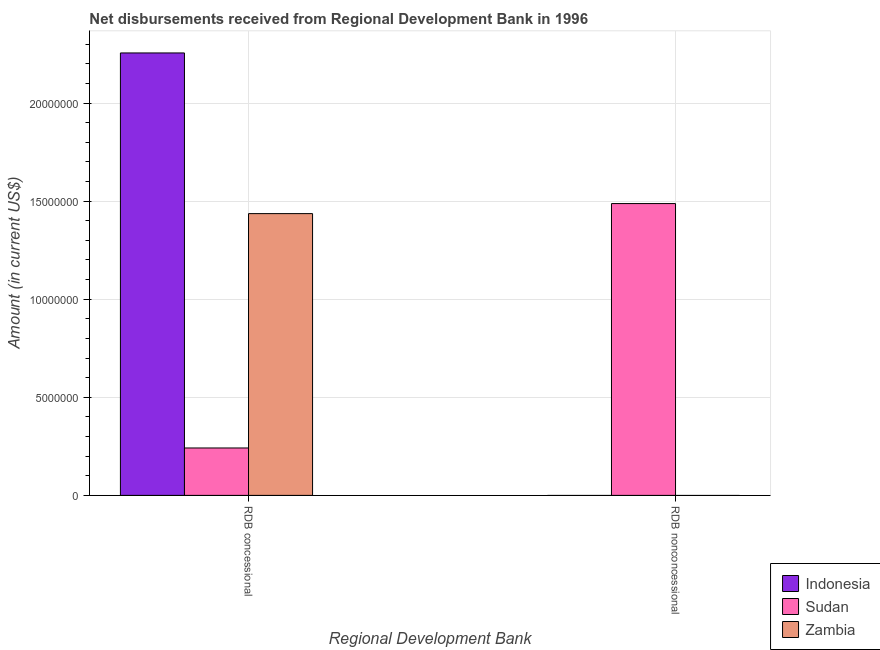How many different coloured bars are there?
Make the answer very short. 3. Are the number of bars per tick equal to the number of legend labels?
Give a very brief answer. No. Are the number of bars on each tick of the X-axis equal?
Offer a very short reply. No. How many bars are there on the 2nd tick from the left?
Provide a succinct answer. 1. What is the label of the 2nd group of bars from the left?
Make the answer very short. RDB nonconcessional. What is the net concessional disbursements from rdb in Indonesia?
Your response must be concise. 2.26e+07. Across all countries, what is the maximum net concessional disbursements from rdb?
Provide a short and direct response. 2.26e+07. Across all countries, what is the minimum net non concessional disbursements from rdb?
Keep it short and to the point. 0. In which country was the net concessional disbursements from rdb maximum?
Give a very brief answer. Indonesia. What is the total net non concessional disbursements from rdb in the graph?
Ensure brevity in your answer.  1.49e+07. What is the difference between the net concessional disbursements from rdb in Zambia and that in Indonesia?
Ensure brevity in your answer.  -8.19e+06. What is the difference between the net non concessional disbursements from rdb in Zambia and the net concessional disbursements from rdb in Sudan?
Offer a terse response. -2.42e+06. What is the average net concessional disbursements from rdb per country?
Offer a very short reply. 1.31e+07. What is the difference between the net non concessional disbursements from rdb and net concessional disbursements from rdb in Sudan?
Make the answer very short. 1.25e+07. What is the ratio of the net concessional disbursements from rdb in Sudan to that in Indonesia?
Provide a short and direct response. 0.11. How many bars are there?
Provide a succinct answer. 4. How many countries are there in the graph?
Provide a succinct answer. 3. Are the values on the major ticks of Y-axis written in scientific E-notation?
Ensure brevity in your answer.  No. Does the graph contain grids?
Provide a succinct answer. Yes. Where does the legend appear in the graph?
Ensure brevity in your answer.  Bottom right. How many legend labels are there?
Offer a very short reply. 3. How are the legend labels stacked?
Provide a succinct answer. Vertical. What is the title of the graph?
Provide a short and direct response. Net disbursements received from Regional Development Bank in 1996. Does "Guinea-Bissau" appear as one of the legend labels in the graph?
Provide a succinct answer. No. What is the label or title of the X-axis?
Provide a short and direct response. Regional Development Bank. What is the Amount (in current US$) in Indonesia in RDB concessional?
Offer a terse response. 2.26e+07. What is the Amount (in current US$) in Sudan in RDB concessional?
Make the answer very short. 2.42e+06. What is the Amount (in current US$) of Zambia in RDB concessional?
Offer a terse response. 1.44e+07. What is the Amount (in current US$) in Indonesia in RDB nonconcessional?
Your answer should be very brief. 0. What is the Amount (in current US$) of Sudan in RDB nonconcessional?
Offer a terse response. 1.49e+07. What is the Amount (in current US$) in Zambia in RDB nonconcessional?
Give a very brief answer. 0. Across all Regional Development Bank, what is the maximum Amount (in current US$) in Indonesia?
Give a very brief answer. 2.26e+07. Across all Regional Development Bank, what is the maximum Amount (in current US$) in Sudan?
Give a very brief answer. 1.49e+07. Across all Regional Development Bank, what is the maximum Amount (in current US$) in Zambia?
Your response must be concise. 1.44e+07. Across all Regional Development Bank, what is the minimum Amount (in current US$) of Indonesia?
Your response must be concise. 0. Across all Regional Development Bank, what is the minimum Amount (in current US$) of Sudan?
Ensure brevity in your answer.  2.42e+06. What is the total Amount (in current US$) of Indonesia in the graph?
Your answer should be very brief. 2.26e+07. What is the total Amount (in current US$) of Sudan in the graph?
Keep it short and to the point. 1.73e+07. What is the total Amount (in current US$) in Zambia in the graph?
Provide a succinct answer. 1.44e+07. What is the difference between the Amount (in current US$) in Sudan in RDB concessional and that in RDB nonconcessional?
Provide a short and direct response. -1.25e+07. What is the difference between the Amount (in current US$) in Indonesia in RDB concessional and the Amount (in current US$) in Sudan in RDB nonconcessional?
Your answer should be compact. 7.68e+06. What is the average Amount (in current US$) in Indonesia per Regional Development Bank?
Offer a terse response. 1.13e+07. What is the average Amount (in current US$) in Sudan per Regional Development Bank?
Offer a terse response. 8.65e+06. What is the average Amount (in current US$) in Zambia per Regional Development Bank?
Offer a very short reply. 7.18e+06. What is the difference between the Amount (in current US$) in Indonesia and Amount (in current US$) in Sudan in RDB concessional?
Provide a succinct answer. 2.01e+07. What is the difference between the Amount (in current US$) of Indonesia and Amount (in current US$) of Zambia in RDB concessional?
Offer a very short reply. 8.19e+06. What is the difference between the Amount (in current US$) of Sudan and Amount (in current US$) of Zambia in RDB concessional?
Your answer should be compact. -1.19e+07. What is the ratio of the Amount (in current US$) in Sudan in RDB concessional to that in RDB nonconcessional?
Offer a terse response. 0.16. What is the difference between the highest and the second highest Amount (in current US$) in Sudan?
Offer a very short reply. 1.25e+07. What is the difference between the highest and the lowest Amount (in current US$) in Indonesia?
Your response must be concise. 2.26e+07. What is the difference between the highest and the lowest Amount (in current US$) of Sudan?
Make the answer very short. 1.25e+07. What is the difference between the highest and the lowest Amount (in current US$) in Zambia?
Your answer should be compact. 1.44e+07. 